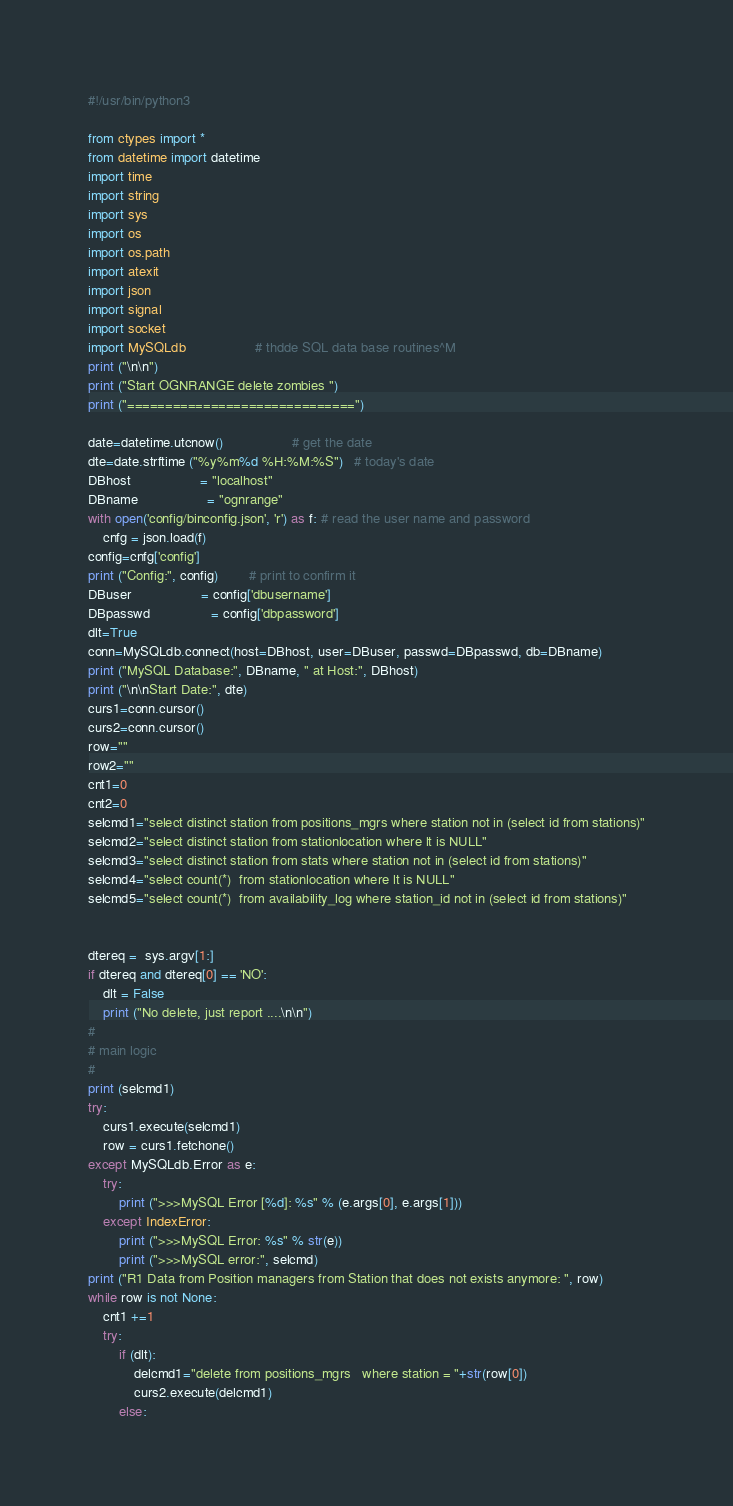Convert code to text. <code><loc_0><loc_0><loc_500><loc_500><_Python_>#!/usr/bin/python3

from ctypes import *
from datetime import datetime
import time
import string
import sys
import os
import os.path
import atexit
import json
import signal
import socket
import MySQLdb                  # thdde SQL data base routines^M
print ("\n\n")
print ("Start OGNRANGE delete zombies ")
print ("==============================")

date=datetime.utcnow()                  # get the date
dte=date.strftime ("%y%m%d %H:%M:%S")   # today's date
DBhost                  = "localhost"
DBname                  = "ognrange"
with open('config/binconfig.json', 'r') as f: # read the user name and password
    cnfg = json.load(f)
config=cnfg['config']
print ("Config:", config)		# print to confirm it
DBuser                  = config['dbusername']
DBpasswd                = config['dbpassword']
dlt=True
conn=MySQLdb.connect(host=DBhost, user=DBuser, passwd=DBpasswd, db=DBname)
print ("MySQL Database:", DBname, " at Host:", DBhost)
print ("\n\nStart Date:", dte)
curs1=conn.cursor()
curs2=conn.cursor()
row=""
row2=""
cnt1=0
cnt2=0
selcmd1="select distinct station from positions_mgrs where station not in (select id from stations)"
selcmd2="select distinct station from stationlocation where lt is NULL"
selcmd3="select distinct station from stats where station not in (select id from stations)"
selcmd4="select count(*)  from stationlocation where lt is NULL"
selcmd5="select count(*)  from availability_log where station_id not in (select id from stations)"


dtereq =  sys.argv[1:]
if dtereq and dtereq[0] == 'NO':
    dlt = False                 
    print ("No delete, just report ....\n\n")
#
# main logic
#
print (selcmd1)
try:
    curs1.execute(selcmd1)
    row = curs1.fetchone()
except MySQLdb.Error as e:
    try:
        print (">>>MySQL Error [%d]: %s" % (e.args[0], e.args[1]))
    except IndexError:
        print (">>>MySQL Error: %s" % str(e))
        print (">>>MySQL error:", selcmd)
print ("R1 Data from Position managers from Station that does not exists anymore: ", row)
while row is not None:
    cnt1 +=1
    try:
        if (dlt):
            delcmd1="delete from positions_mgrs   where station = "+str(row[0])
            curs2.execute(delcmd1)
        else:</code> 